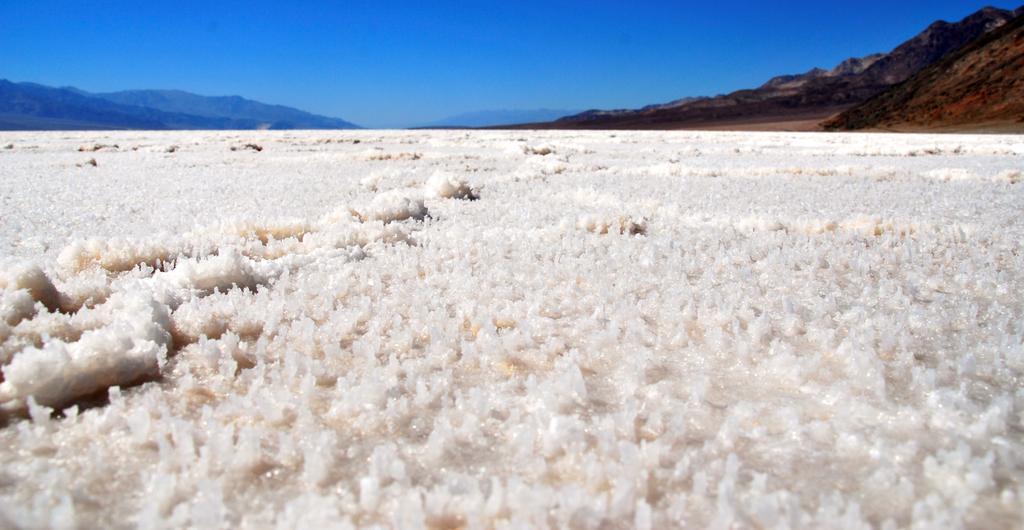Could you give a brief overview of what you see in this image? In the down side there is snow and in the right side there are hills. At the top it's a blue color sky. 